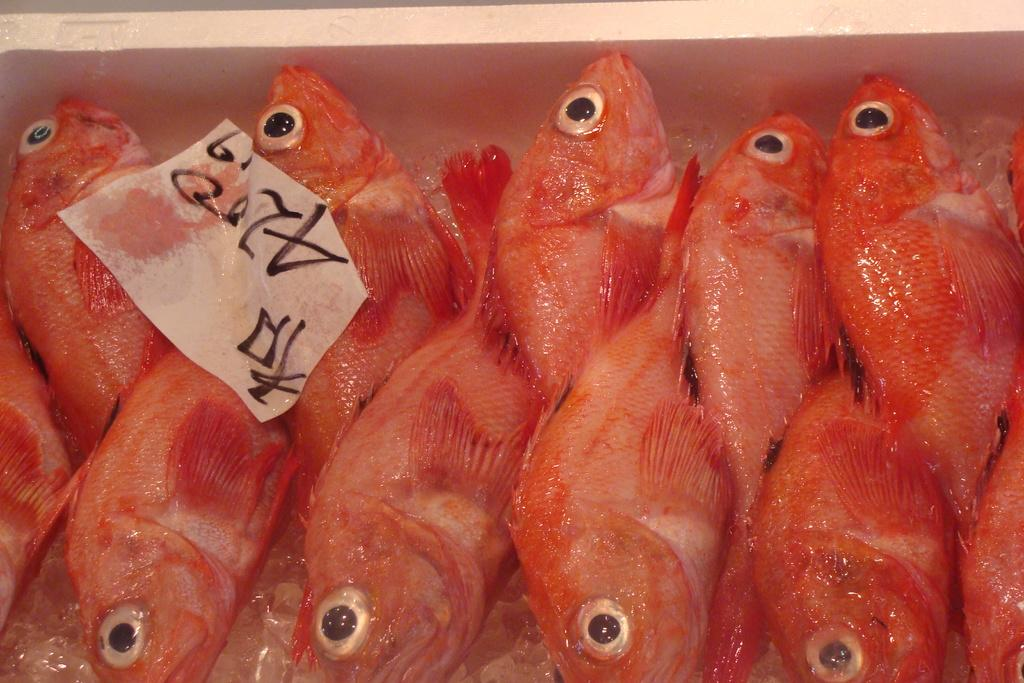What type of animals can be seen in the image? There are many fish in the image. What color are the fish? The fish are in orange color. What else is present in the image besides the fish? There is a white color paper with something written on it in the image. What type of lettuce can be seen in the image? There is no lettuce present in the image; it features many orange fish and a white paper with writing on it. What type of fowl is visible in the image? There is no fowl present in the image; it features many orange fish and a white paper with writing on it. 